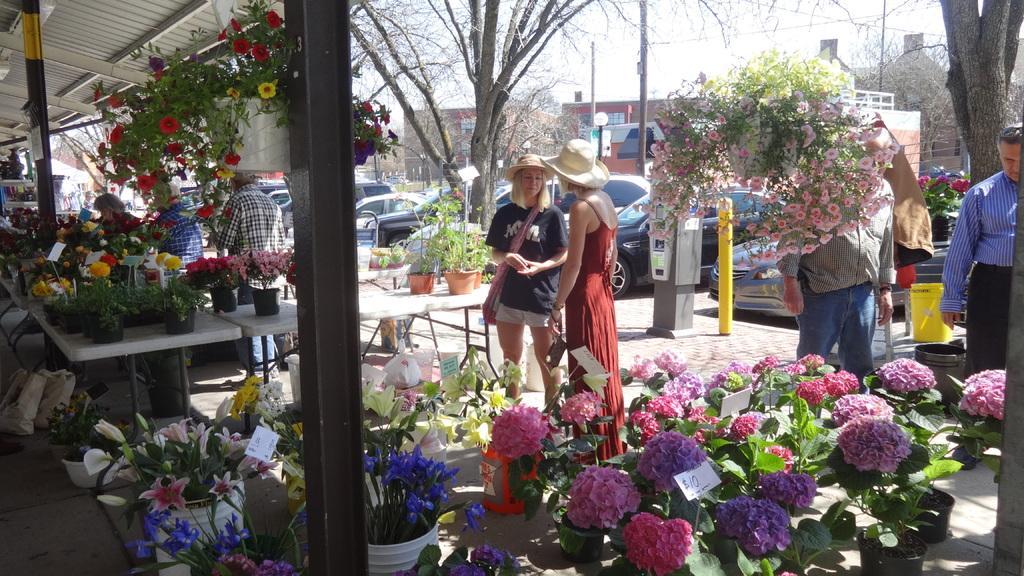Can you describe this image briefly? In this image there are so many colorful flower pots. There are people standing. There are trees. The cars are parked. There is a building on the backside. There is a sky. 